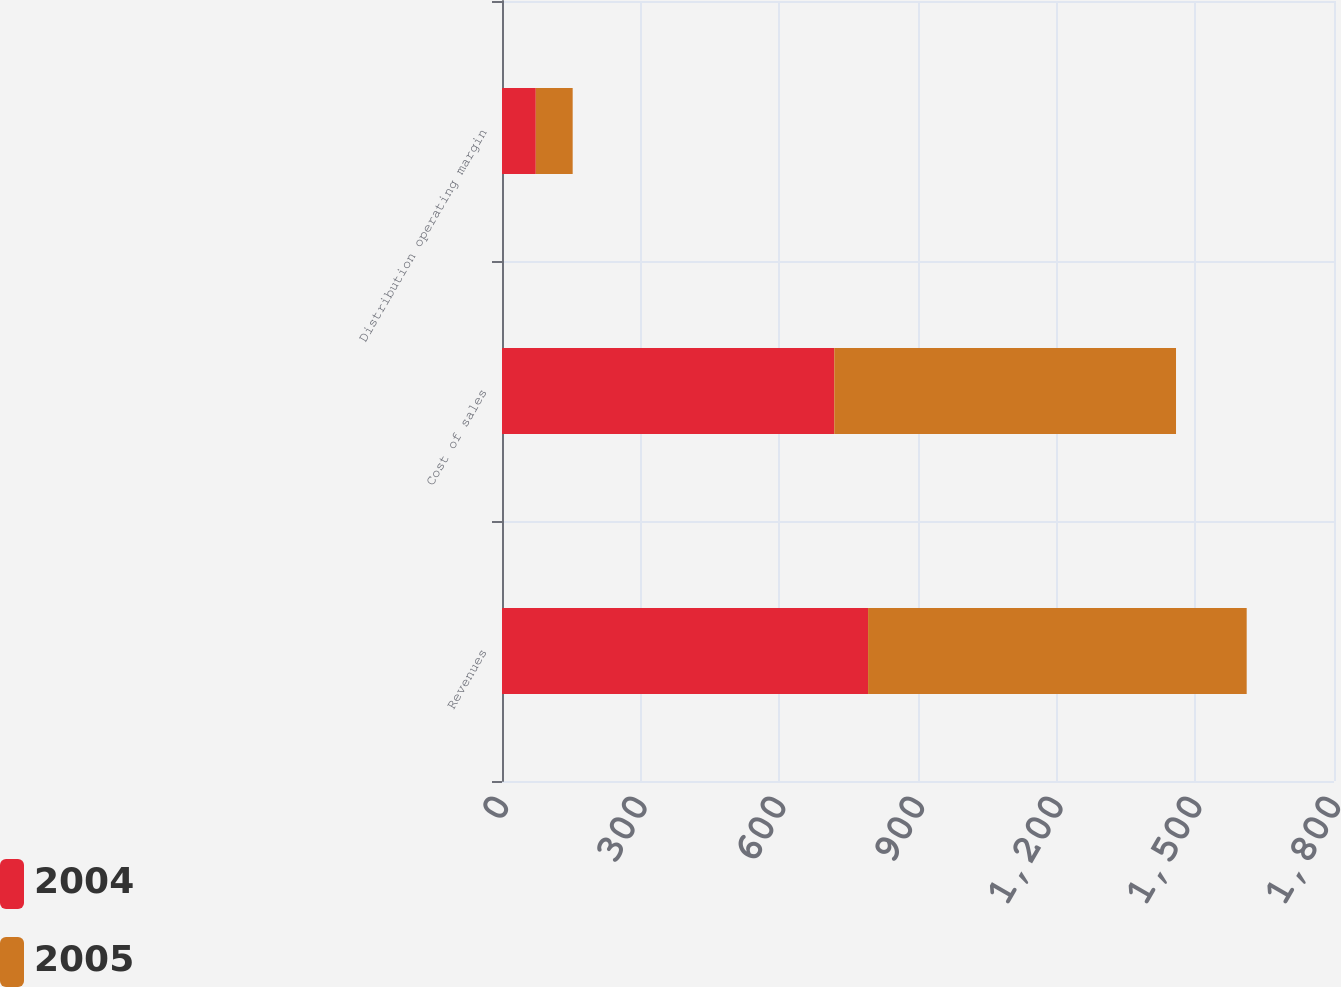<chart> <loc_0><loc_0><loc_500><loc_500><stacked_bar_chart><ecel><fcel>Revenues<fcel>Cost of sales<fcel>Distribution operating margin<nl><fcel>2004<fcel>792<fcel>718.9<fcel>73.1<nl><fcel>2005<fcel>819.1<fcel>739.3<fcel>79.8<nl></chart> 